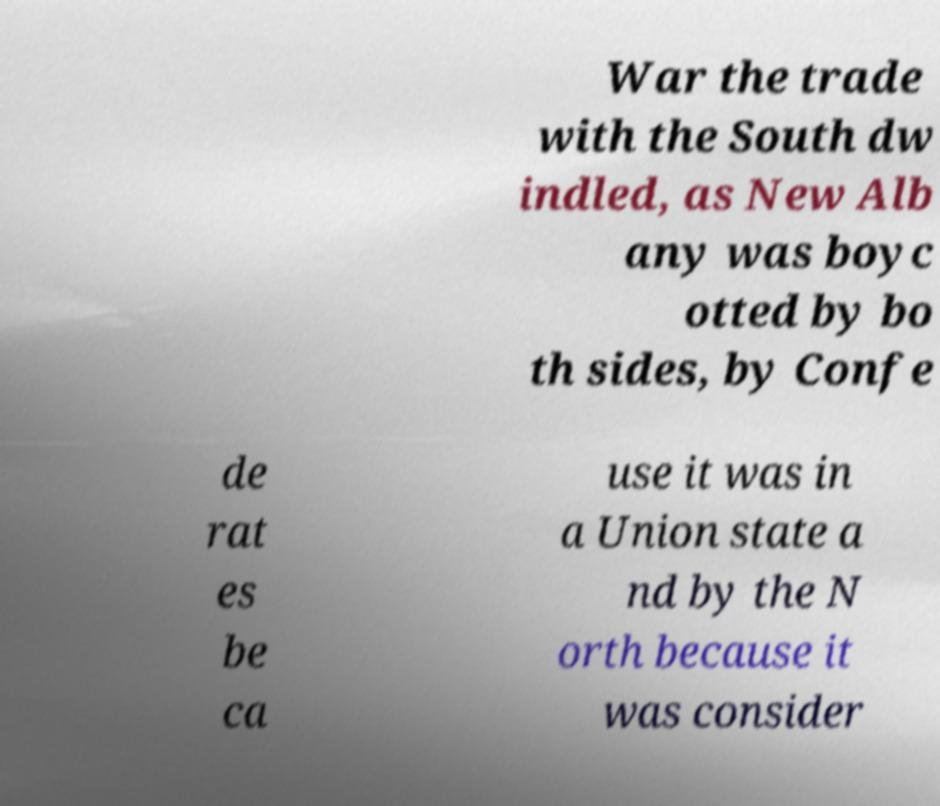I need the written content from this picture converted into text. Can you do that? War the trade with the South dw indled, as New Alb any was boyc otted by bo th sides, by Confe de rat es be ca use it was in a Union state a nd by the N orth because it was consider 